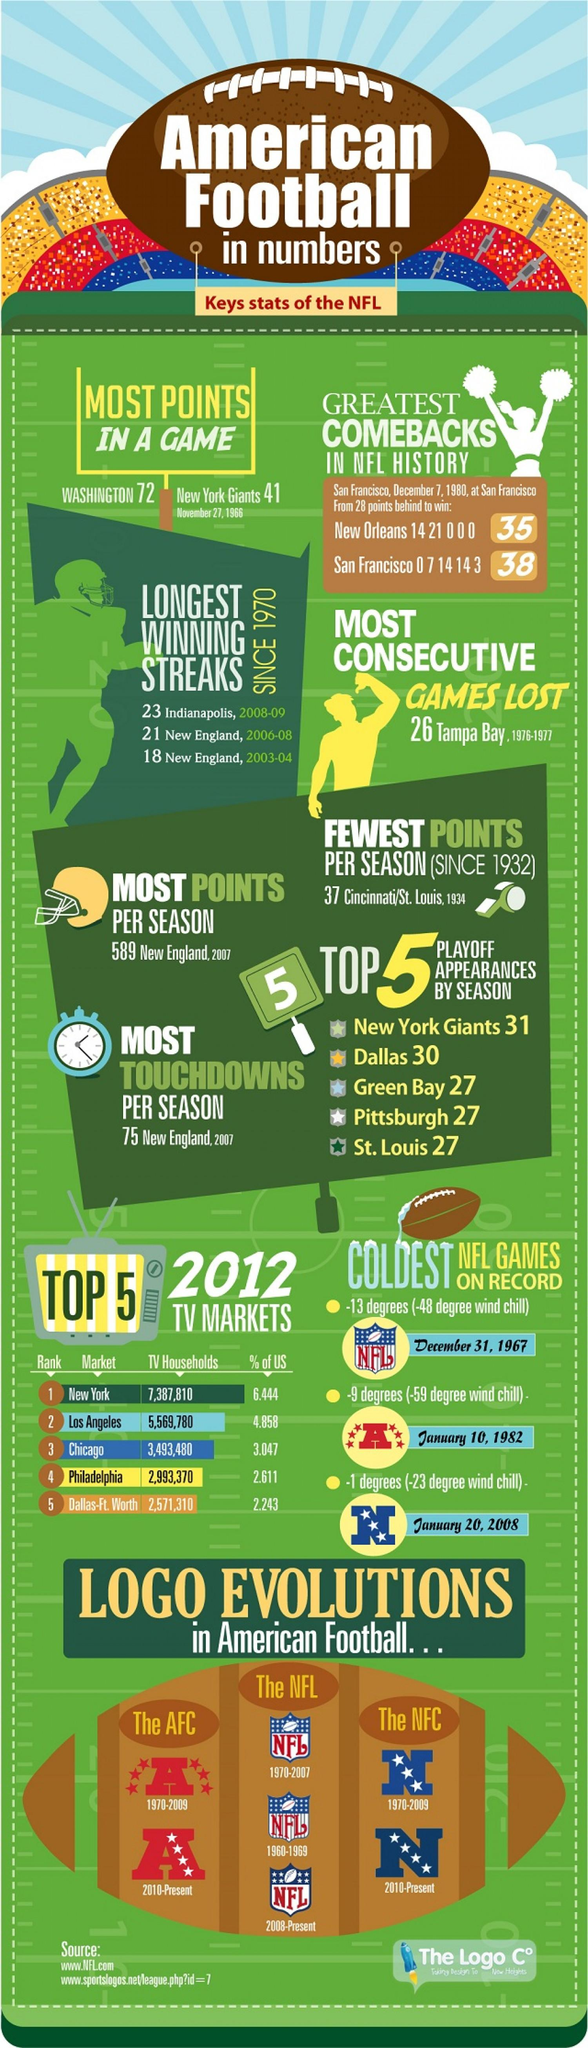Mention a couple of crucial points in this snapshot. As of 2008-present, the NFL logo features 8 stars. The coldest AFC game on record was played on January 10, 1982. There are four stars present in the logo of the NFC from 2010-present. The color of the stars present in the logo of NFC is primarily white. During the 1976-1977 NFL season, a record was set for the most consecutive games lost by a team. 